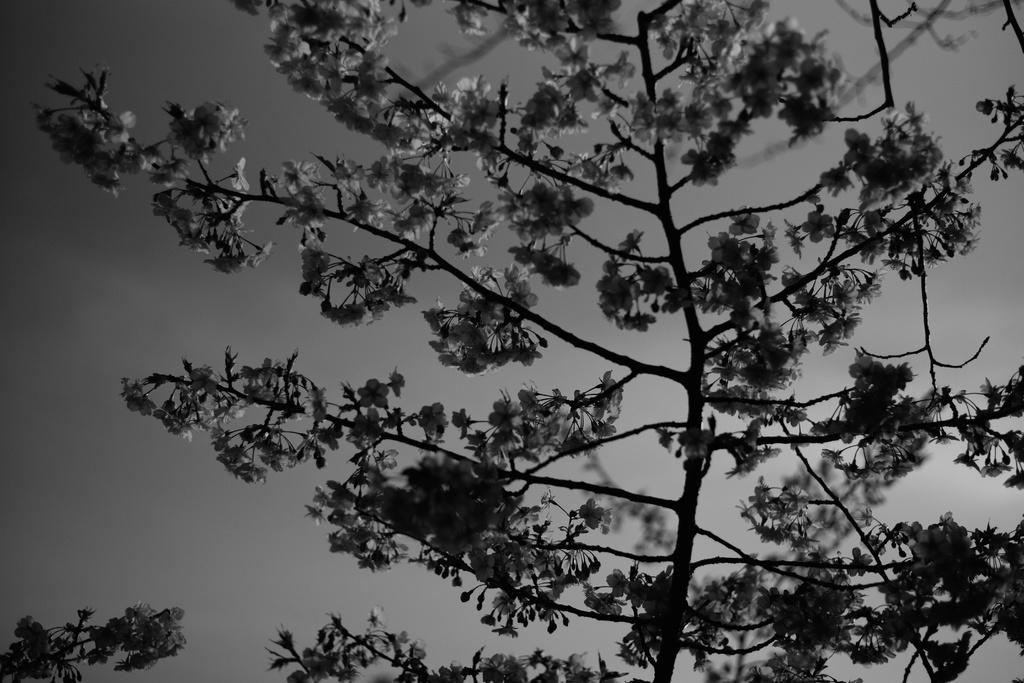What is the main object in the image? There is a tree in the image. What is special about the tree? The tree has flowers. What can be seen in the background of the image? The sky is visible in the background of the image. What type of pickle is hanging from the tree in the image? There is no pickle present in the image; it features a tree with flowers. What does the caption say about the tree in the image? There is no caption provided with the image, so we cannot determine what it might say about the tree. 